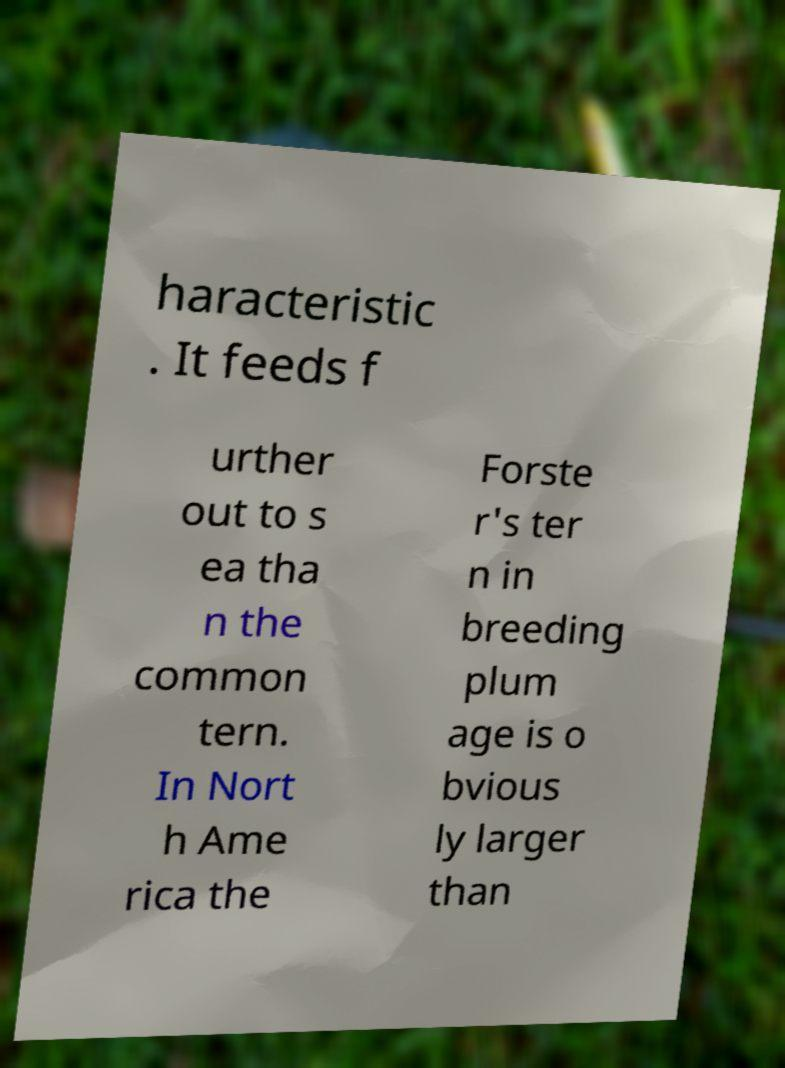I need the written content from this picture converted into text. Can you do that? haracteristic . It feeds f urther out to s ea tha n the common tern. In Nort h Ame rica the Forste r's ter n in breeding plum age is o bvious ly larger than 